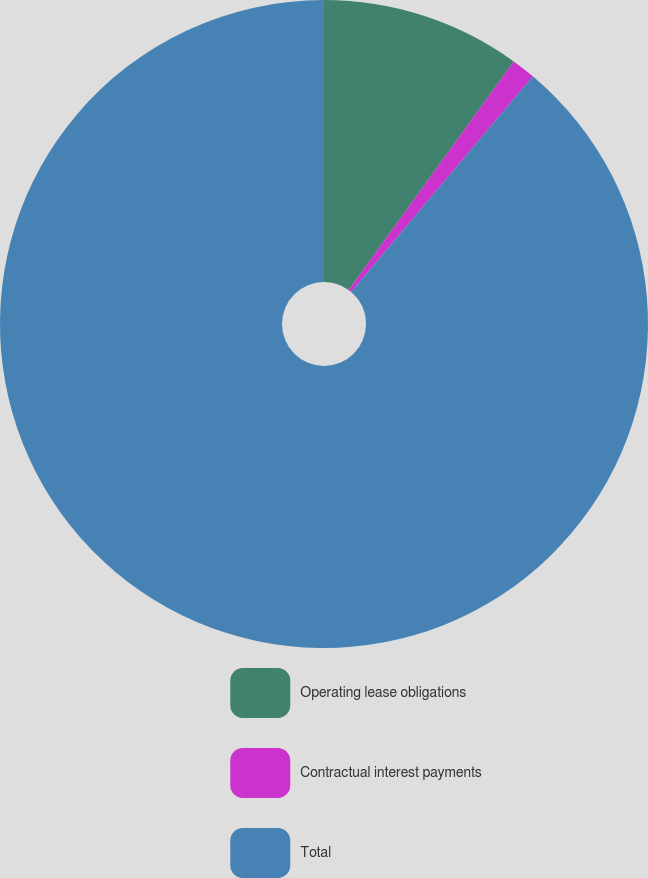<chart> <loc_0><loc_0><loc_500><loc_500><pie_chart><fcel>Operating lease obligations<fcel>Contractual interest payments<fcel>Total<nl><fcel>9.96%<fcel>1.19%<fcel>88.86%<nl></chart> 